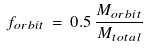<formula> <loc_0><loc_0><loc_500><loc_500>f _ { o r b i t } \, = \, 0 . 5 \, \frac { M _ { o r b i t } } { M _ { t o t a l } }</formula> 